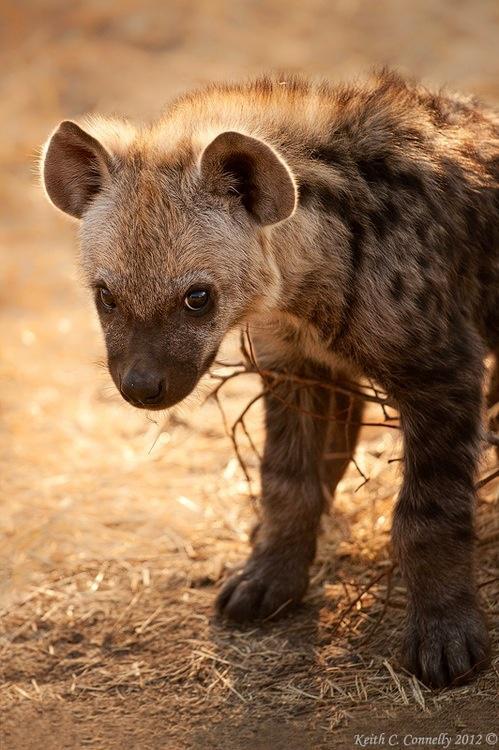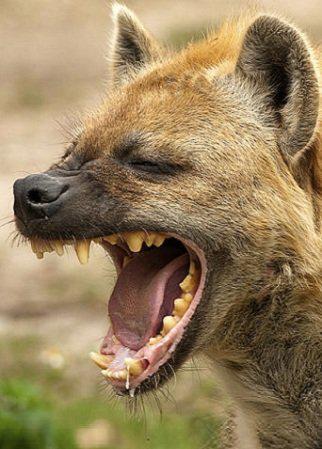The first image is the image on the left, the second image is the image on the right. Considering the images on both sides, is "There is an animal with its mouth open in one of the images." valid? Answer yes or no. Yes. 